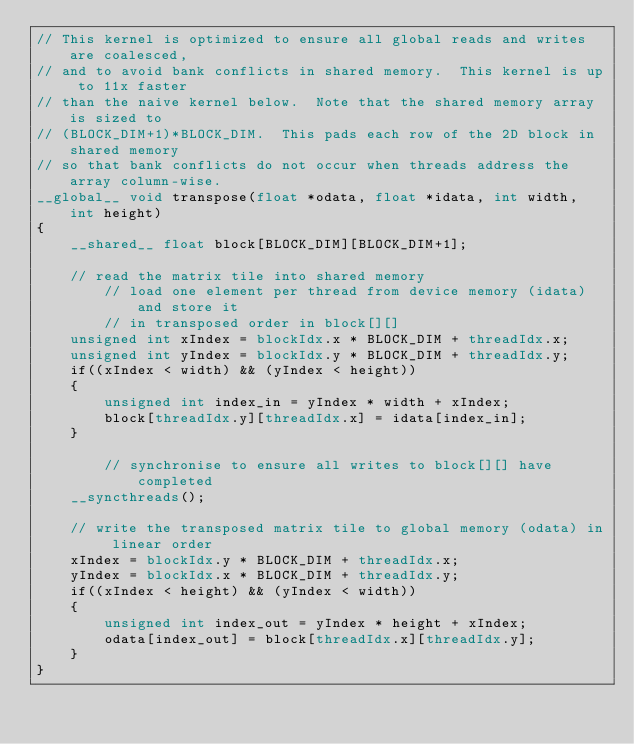Convert code to text. <code><loc_0><loc_0><loc_500><loc_500><_Cuda_>// This kernel is optimized to ensure all global reads and writes are coalesced,
// and to avoid bank conflicts in shared memory.  This kernel is up to 11x faster
// than the naive kernel below.  Note that the shared memory array is sized to 
// (BLOCK_DIM+1)*BLOCK_DIM.  This pads each row of the 2D block in shared memory 
// so that bank conflicts do not occur when threads address the array column-wise.
__global__ void transpose(float *odata, float *idata, int width, int height)
{
	__shared__ float block[BLOCK_DIM][BLOCK_DIM+1];
	
	// read the matrix tile into shared memory
        // load one element per thread from device memory (idata) and store it
        // in transposed order in block[][]
	unsigned int xIndex = blockIdx.x * BLOCK_DIM + threadIdx.x;
	unsigned int yIndex = blockIdx.y * BLOCK_DIM + threadIdx.y;
	if((xIndex < width) && (yIndex < height))
	{
		unsigned int index_in = yIndex * width + xIndex;
		block[threadIdx.y][threadIdx.x] = idata[index_in];
	}

        // synchronise to ensure all writes to block[][] have completed
	__syncthreads();

	// write the transposed matrix tile to global memory (odata) in linear order
	xIndex = blockIdx.y * BLOCK_DIM + threadIdx.x;
	yIndex = blockIdx.x * BLOCK_DIM + threadIdx.y;
	if((xIndex < height) && (yIndex < width))
	{
		unsigned int index_out = yIndex * height + xIndex;
		odata[index_out] = block[threadIdx.x][threadIdx.y];
	}
}
</code> 